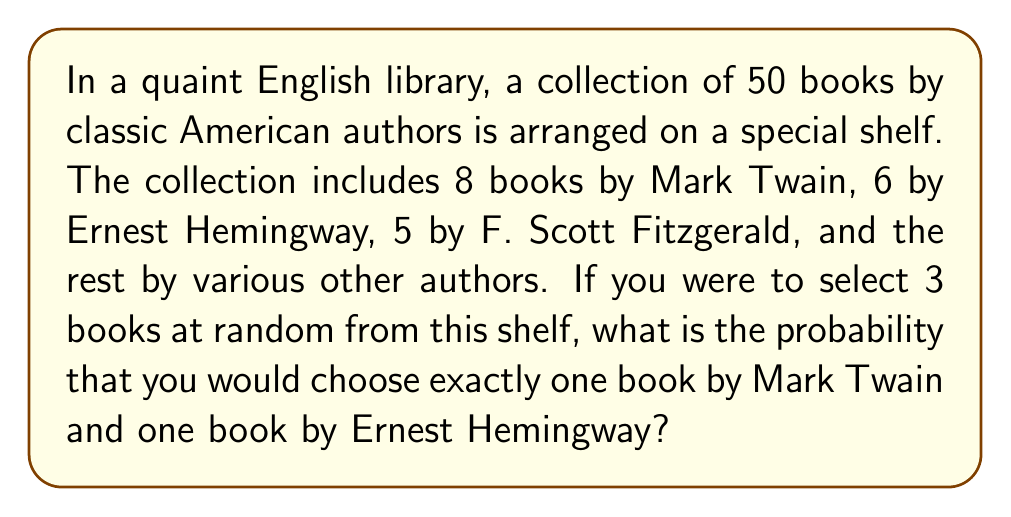Give your solution to this math problem. Let's approach this step-by-step:

1) First, we need to calculate the total number of ways to select 3 books from 50. This can be done using the combination formula:

   $$\binom{50}{3} = \frac{50!}{3!(50-3)!} = \frac{50!}{3!47!} = 19,600$$

2) Now, we need to calculate the number of ways to select:
   - 1 book by Mark Twain (out of 8)
   - 1 book by Hemingway (out of 6)
   - 1 book by any other author (50 - 8 - 6 = 36 books)

   This can be calculated as follows:

   $$\binom{8}{1} \times \binom{6}{1} \times \binom{36}{1} = 8 \times 6 \times 36 = 1,728$$

3) The probability is then the number of favorable outcomes divided by the total number of possible outcomes:

   $$P(\text{1 Twain, 1 Hemingway, 1 Other}) = \frac{1,728}{19,600} = \frac{54}{613} \approx 0.0881$$
Answer: $\frac{54}{613}$ or approximately 0.0881 or 8.81% 